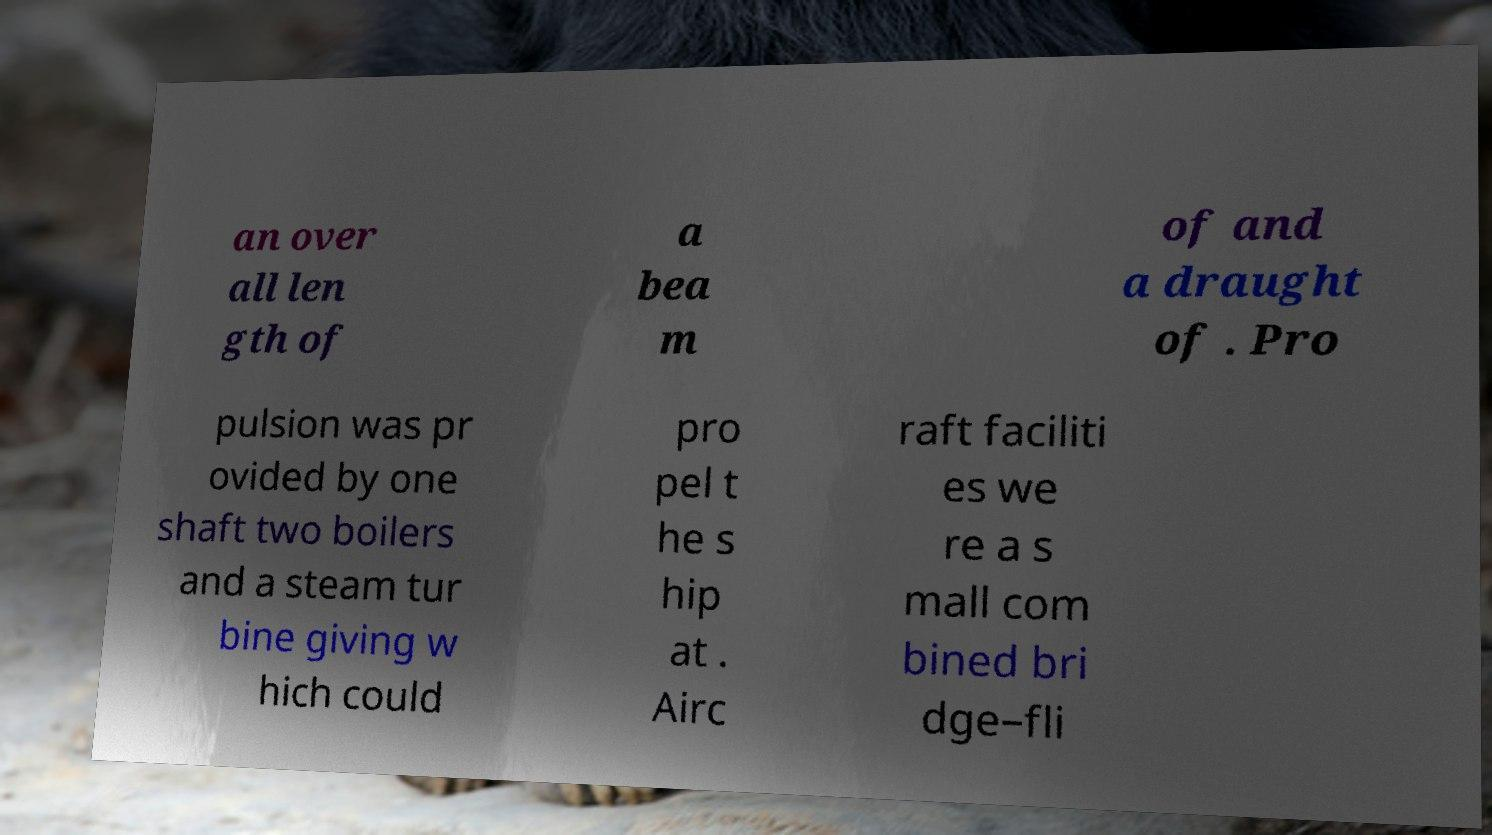Can you read and provide the text displayed in the image?This photo seems to have some interesting text. Can you extract and type it out for me? an over all len gth of a bea m of and a draught of . Pro pulsion was pr ovided by one shaft two boilers and a steam tur bine giving w hich could pro pel t he s hip at . Airc raft faciliti es we re a s mall com bined bri dge–fli 